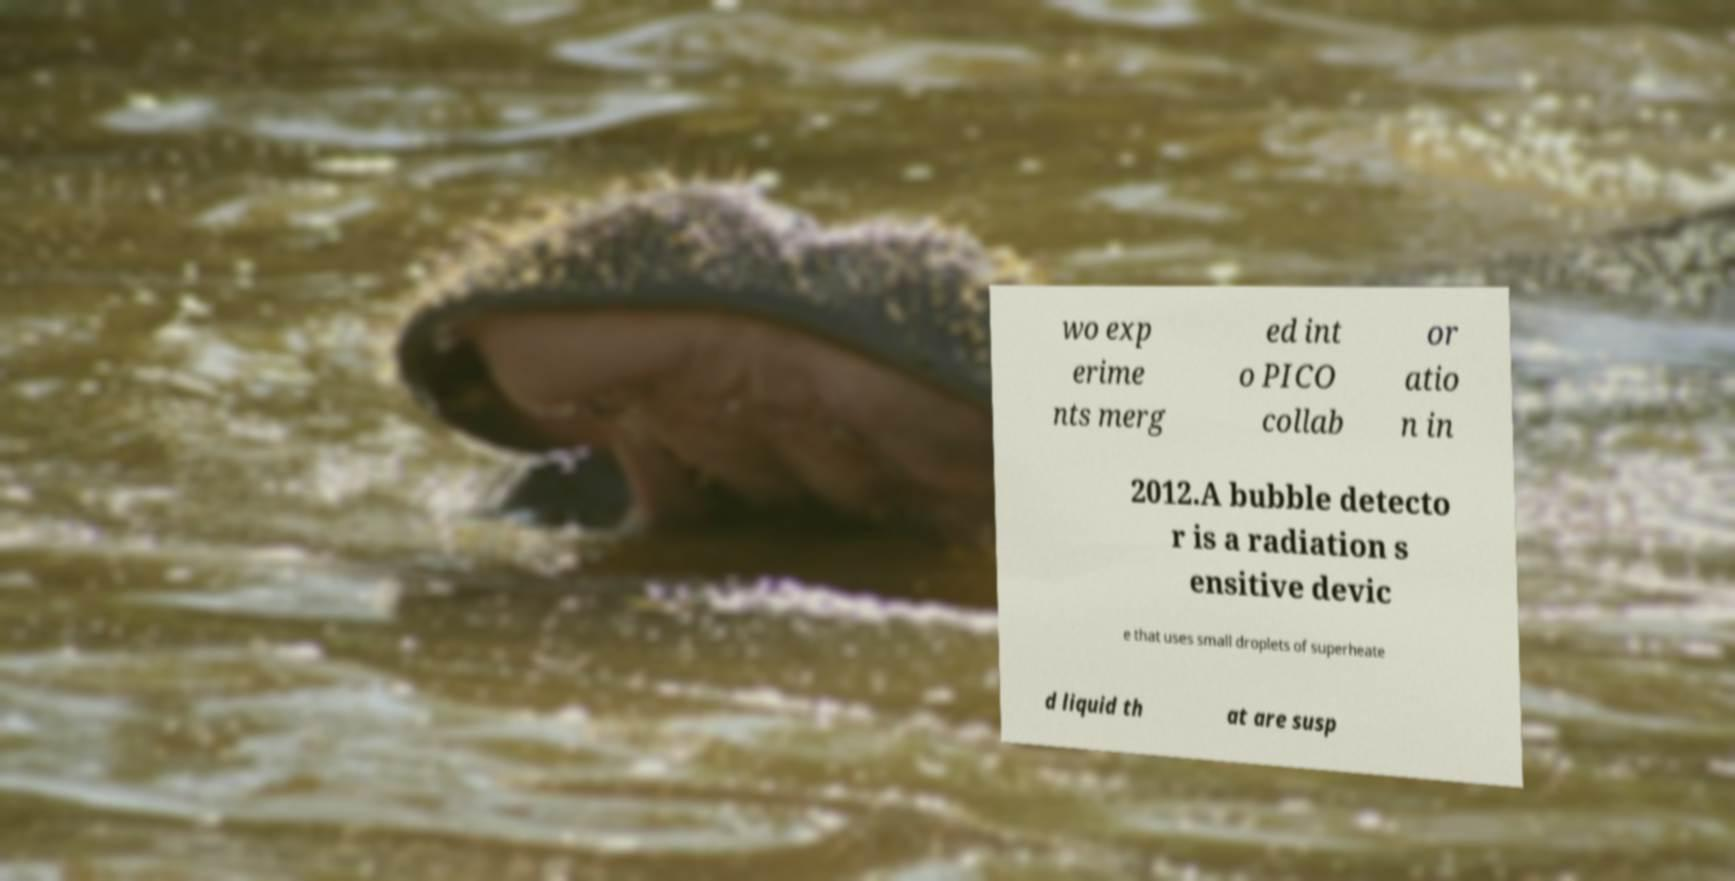Can you accurately transcribe the text from the provided image for me? wo exp erime nts merg ed int o PICO collab or atio n in 2012.A bubble detecto r is a radiation s ensitive devic e that uses small droplets of superheate d liquid th at are susp 